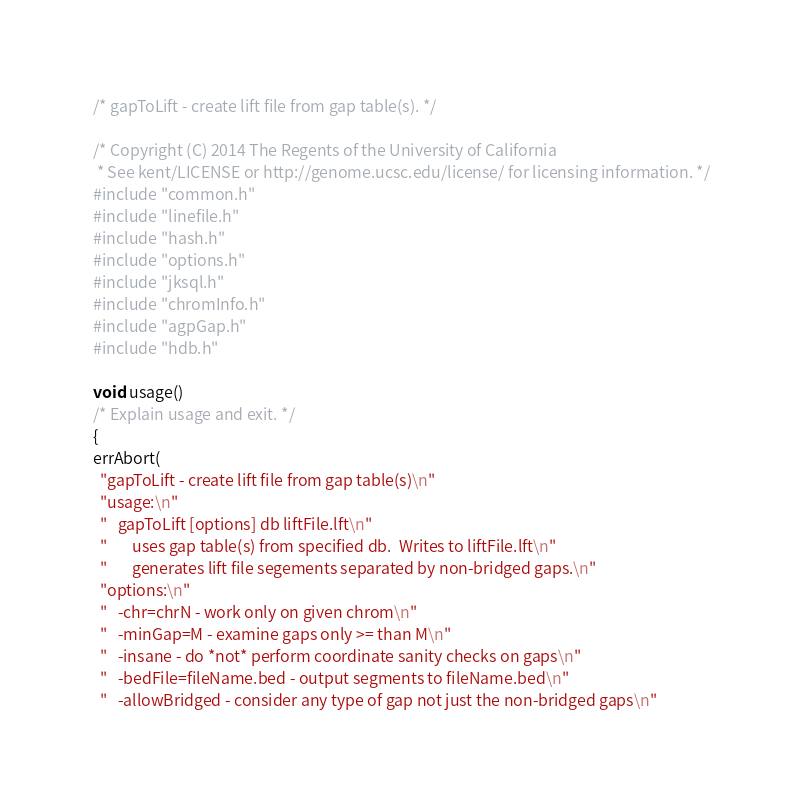Convert code to text. <code><loc_0><loc_0><loc_500><loc_500><_C_>/* gapToLift - create lift file from gap table(s). */

/* Copyright (C) 2014 The Regents of the University of California 
 * See kent/LICENSE or http://genome.ucsc.edu/license/ for licensing information. */
#include "common.h"
#include "linefile.h"
#include "hash.h"
#include "options.h"
#include "jksql.h"
#include "chromInfo.h"
#include "agpGap.h"
#include "hdb.h"

void usage()
/* Explain usage and exit. */
{
errAbort(
  "gapToLift - create lift file from gap table(s)\n"
  "usage:\n"
  "   gapToLift [options] db liftFile.lft\n"
  "       uses gap table(s) from specified db.  Writes to liftFile.lft\n"
  "       generates lift file segements separated by non-bridged gaps.\n"
  "options:\n"
  "   -chr=chrN - work only on given chrom\n"
  "   -minGap=M - examine gaps only >= than M\n"
  "   -insane - do *not* perform coordinate sanity checks on gaps\n"
  "   -bedFile=fileName.bed - output segments to fileName.bed\n"
  "   -allowBridged - consider any type of gap not just the non-bridged gaps\n"</code> 